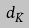Convert formula to latex. <formula><loc_0><loc_0><loc_500><loc_500>d _ { \hat { K } }</formula> 